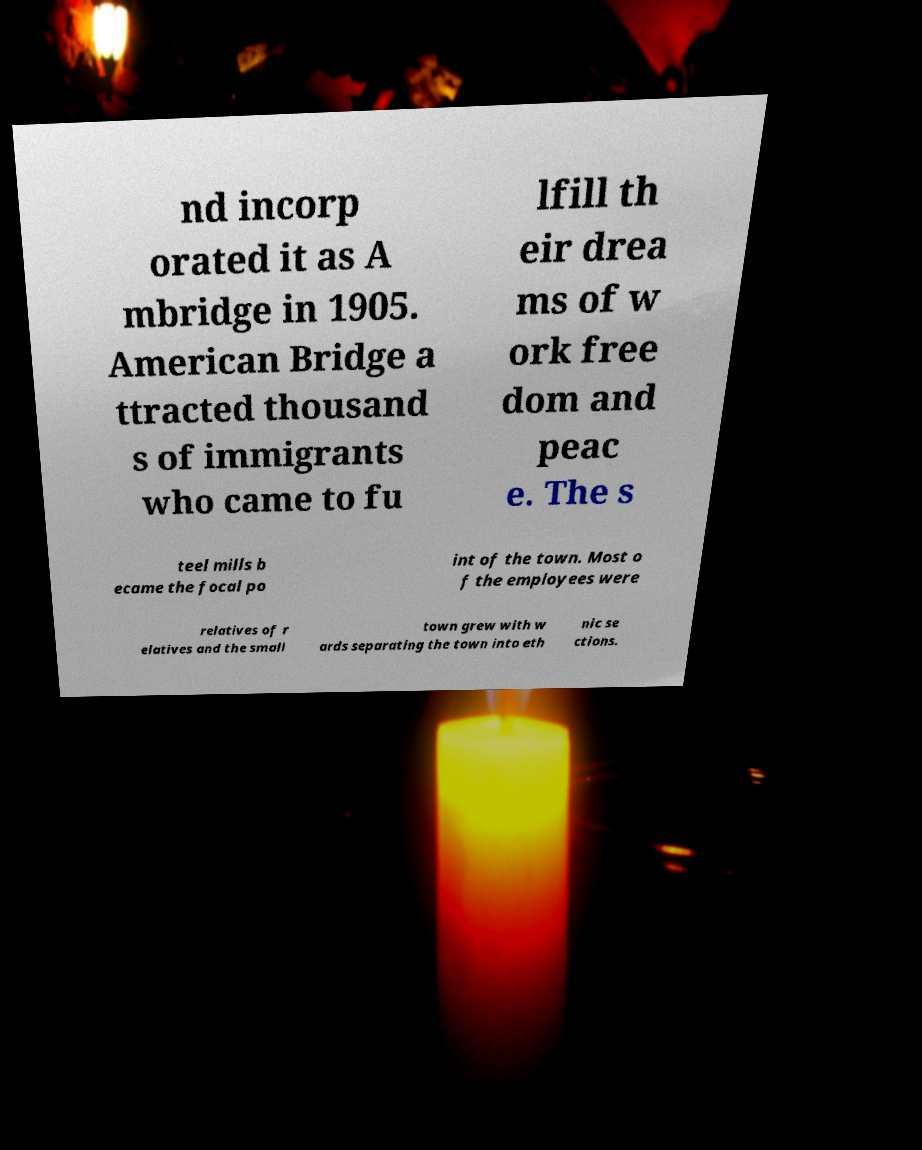Can you read and provide the text displayed in the image?This photo seems to have some interesting text. Can you extract and type it out for me? nd incorp orated it as A mbridge in 1905. American Bridge a ttracted thousand s of immigrants who came to fu lfill th eir drea ms of w ork free dom and peac e. The s teel mills b ecame the focal po int of the town. Most o f the employees were relatives of r elatives and the small town grew with w ards separating the town into eth nic se ctions. 